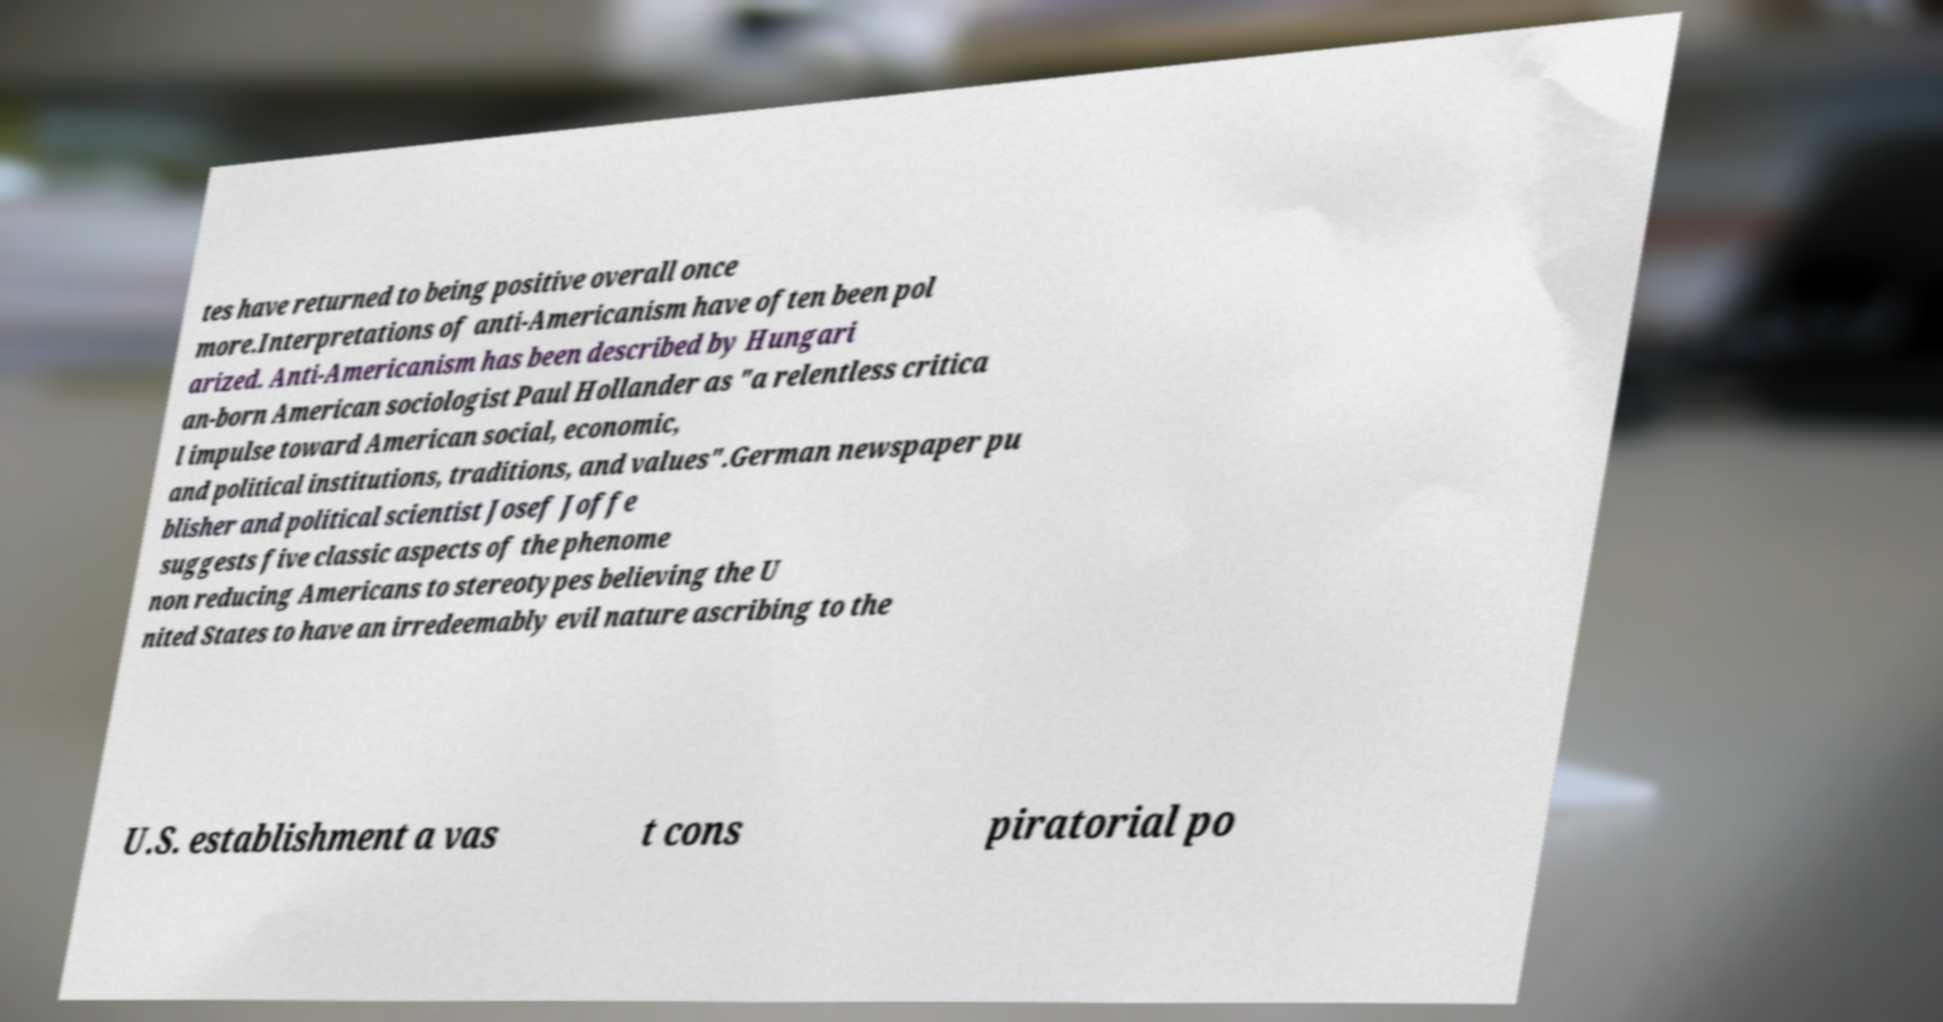Can you accurately transcribe the text from the provided image for me? tes have returned to being positive overall once more.Interpretations of anti-Americanism have often been pol arized. Anti-Americanism has been described by Hungari an-born American sociologist Paul Hollander as "a relentless critica l impulse toward American social, economic, and political institutions, traditions, and values".German newspaper pu blisher and political scientist Josef Joffe suggests five classic aspects of the phenome non reducing Americans to stereotypes believing the U nited States to have an irredeemably evil nature ascribing to the U.S. establishment a vas t cons piratorial po 